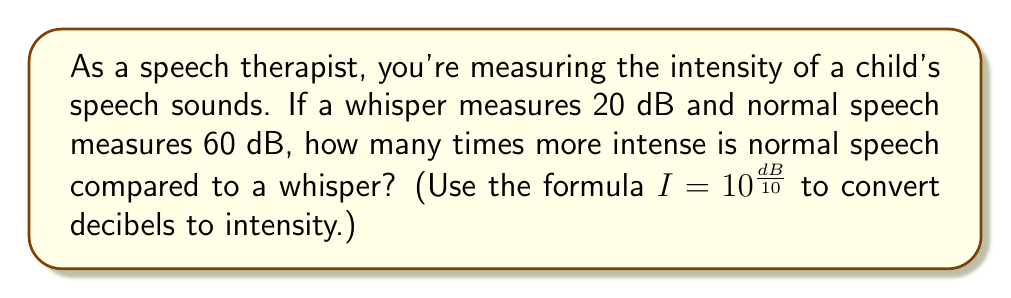Give your solution to this math problem. Let's approach this step-by-step:

1) We're given that:
   - Whisper = 20 dB
   - Normal speech = 60 dB

2) We need to convert these dB values to intensity using the formula:
   $I = 10^{\frac{dB}{10}}$

3) For whisper:
   $I_w = 10^{\frac{20}{10}} = 10^2 = 100$

4) For normal speech:
   $I_n = 10^{\frac{60}{10}} = 10^6 = 1,000,000$

5) To find how many times more intense normal speech is, we divide:

   $$\frac{I_n}{I_w} = \frac{1,000,000}{100} = 10,000$$

Therefore, normal speech is 10,000 times more intense than a whisper.
Answer: 10,000 times 